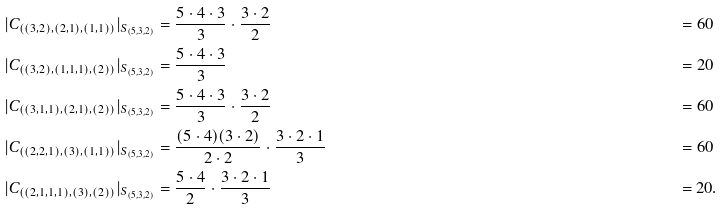<formula> <loc_0><loc_0><loc_500><loc_500>| C _ { ( ( 3 , 2 ) , ( 2 , 1 ) , ( 1 , 1 ) ) } | _ { S _ { ( 5 , 3 , 2 ) } } & = \frac { 5 \cdot 4 \cdot 3 } { 3 } \cdot \frac { 3 \cdot 2 } { 2 } & = 6 0 \ \\ | C _ { ( ( 3 , 2 ) , ( 1 , 1 , 1 ) , ( 2 ) ) } | _ { S _ { ( 5 , 3 , 2 ) } } & = \frac { 5 \cdot 4 \cdot 3 } { 3 } & = 2 0 \ \\ | C _ { ( ( 3 , 1 , 1 ) , ( 2 , 1 ) , ( 2 ) ) } | _ { S _ { ( 5 , 3 , 2 ) } } & = \frac { 5 \cdot 4 \cdot 3 } { 3 } \cdot \frac { 3 \cdot 2 } { 2 } & = 6 0 \ \\ | C _ { ( ( 2 , 2 , 1 ) , ( 3 ) , ( 1 , 1 ) ) } | _ { S _ { ( 5 , 3 , 2 ) } } & = \frac { ( 5 \cdot 4 ) ( 3 \cdot 2 ) } { 2 \cdot 2 } \cdot \frac { 3 \cdot 2 \cdot 1 } { 3 } & = 6 0 \ \\ | C _ { ( ( 2 , 1 , 1 , 1 ) , ( 3 ) , ( 2 ) ) } | _ { S _ { ( 5 , 3 , 2 ) } } & = \frac { 5 \cdot 4 } { 2 } \cdot \frac { 3 \cdot 2 \cdot 1 } { 3 } & = 2 0 .</formula> 